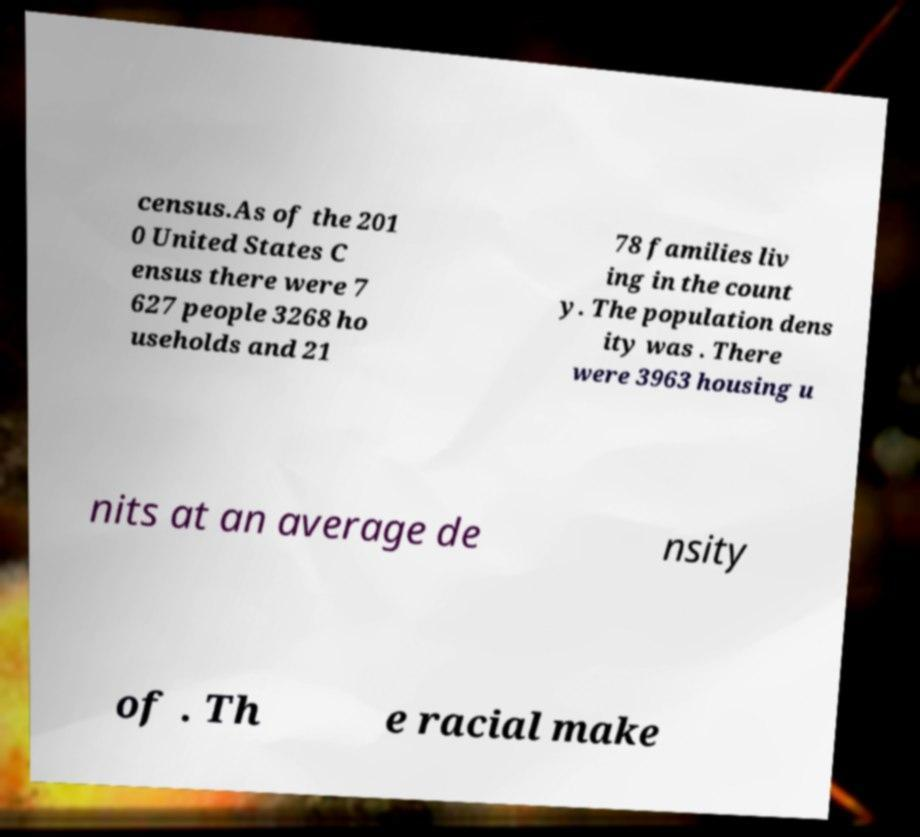I need the written content from this picture converted into text. Can you do that? census.As of the 201 0 United States C ensus there were 7 627 people 3268 ho useholds and 21 78 families liv ing in the count y. The population dens ity was . There were 3963 housing u nits at an average de nsity of . Th e racial make 